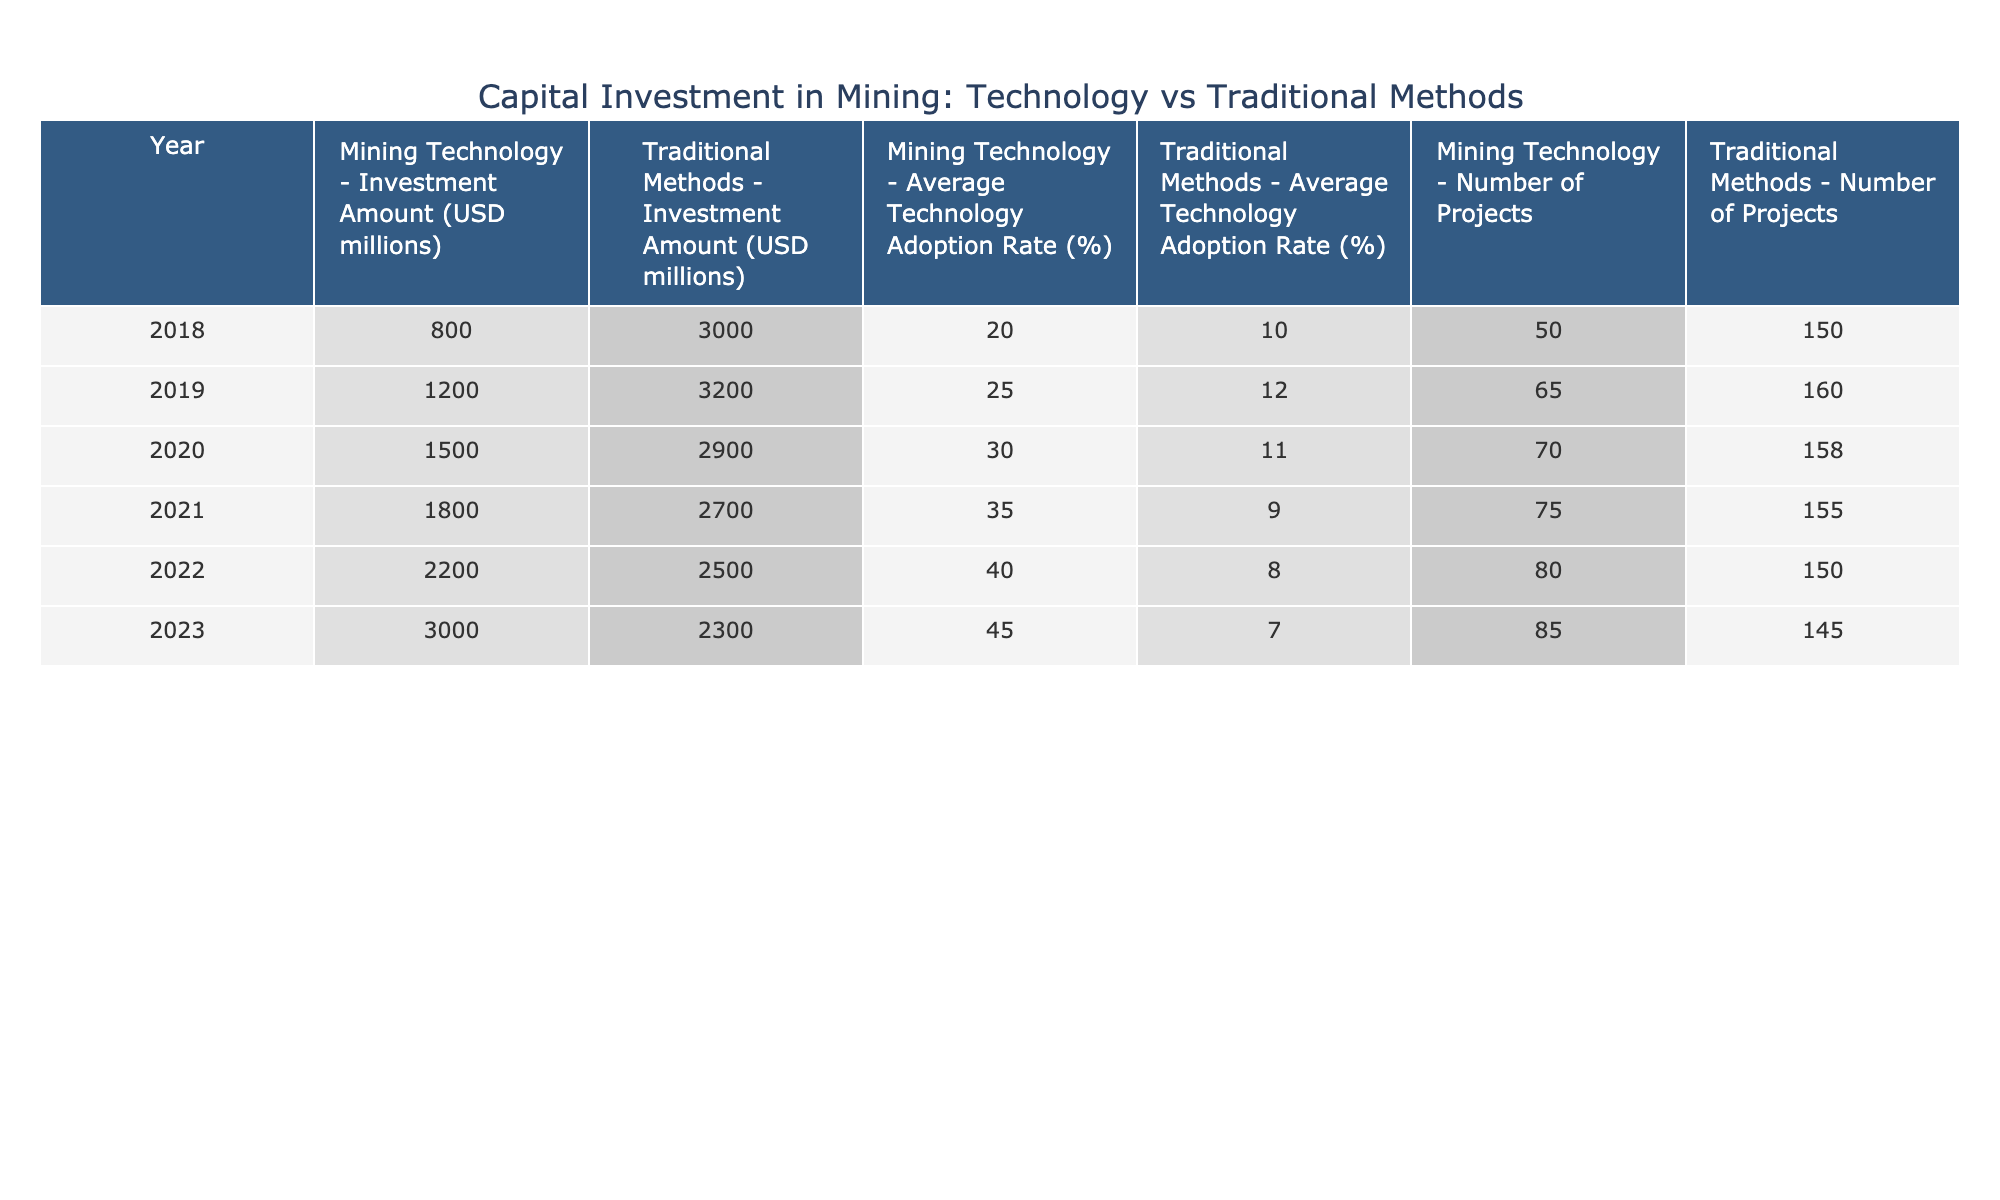What was the capital investment in mining technology in 2020? In the table, under the year 2020 and the investment type 'Mining Technology', the investment amount listed is 1500 million USD.
Answer: 1500 million USD What is the average technology adoption rate for traditional methods in 2021? Looking at the row for the year 2021 and the investment type 'Traditional Methods', the average technology adoption rate is 9%.
Answer: 9% What is the total investment amount for mining technology from 2018 to 2023? To find the total, sum the investments for mining technology: 800 + 1200 + 1500 + 1800 + 2200 + 3000 = 10500 million USD.
Answer: 10500 million USD Was there a decline in the number of traditional projects from 2018 to 2023? Comparing the number of traditional projects, it started at 150 in 2018 and dropped to 145 in 2023, indicating a decline.
Answer: Yes In which year did mining technology have the highest average technology adoption rate, and what was that rate? The highest average technology adoption rate for mining technology is found in the year 2023, where it is 45%.
Answer: 2023, 45% What is the percentage increase in investment amount in mining technology from 2019 to 2023? The investment amount in 2019 is 1200 million USD, and in 2023 it is 3000 million USD. The increase is (3000 - 1200) / 1200 * 100 = 150%.
Answer: 150% What was the lowest investment amount for traditional methods, and in which year did it occur? By reviewing the investments for traditional methods, the lowest amount is 2300 million USD, which is in 2023.
Answer: 2300 million USD, 2023 Do the traditional methods have a higher average investment amount compared to mining technology in 2020? In 2020, traditional methods had an investment of 2900 million USD while mining technology had 1500 million USD, so traditional methods had a higher average.
Answer: Yes What was the trend in the average technology adoption rate of mining technology from 2018 to 2023? The average technology adoption rate for mining technology increased from 20% in 2018, to 25% in 2019, to 30% in 2020, to 35% in 2021, to 40% in 2022, and finally to 45% in 2023. Thus, it shows a consistent increase.
Answer: Increasing 